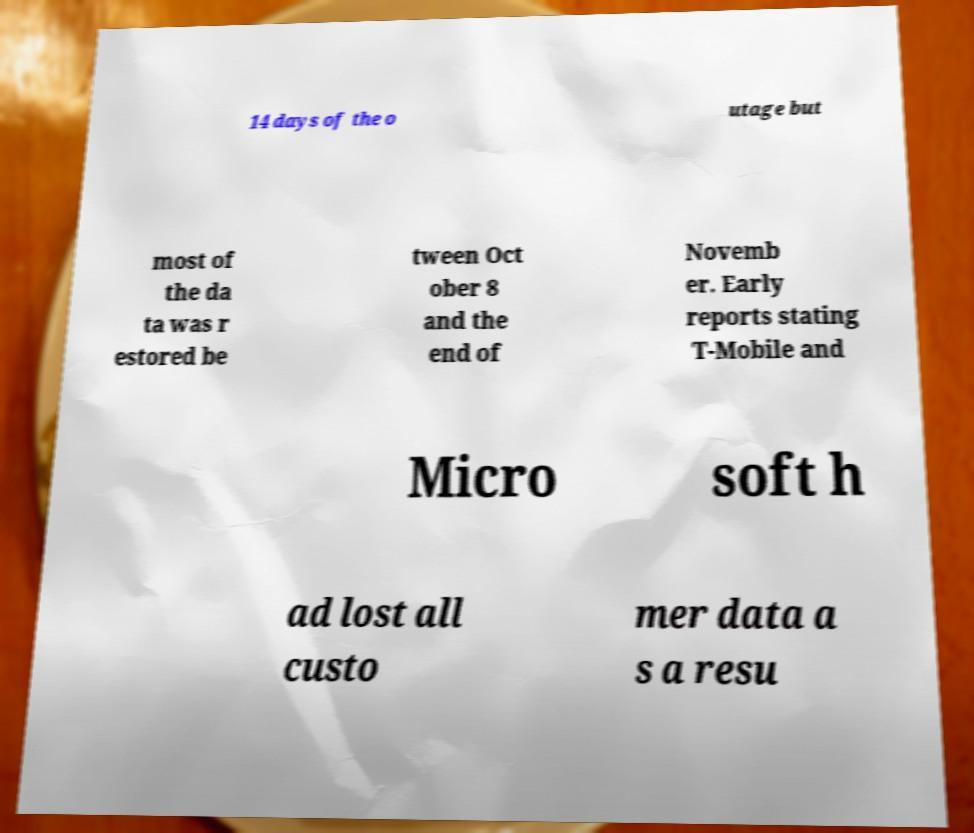I need the written content from this picture converted into text. Can you do that? 14 days of the o utage but most of the da ta was r estored be tween Oct ober 8 and the end of Novemb er. Early reports stating T-Mobile and Micro soft h ad lost all custo mer data a s a resu 